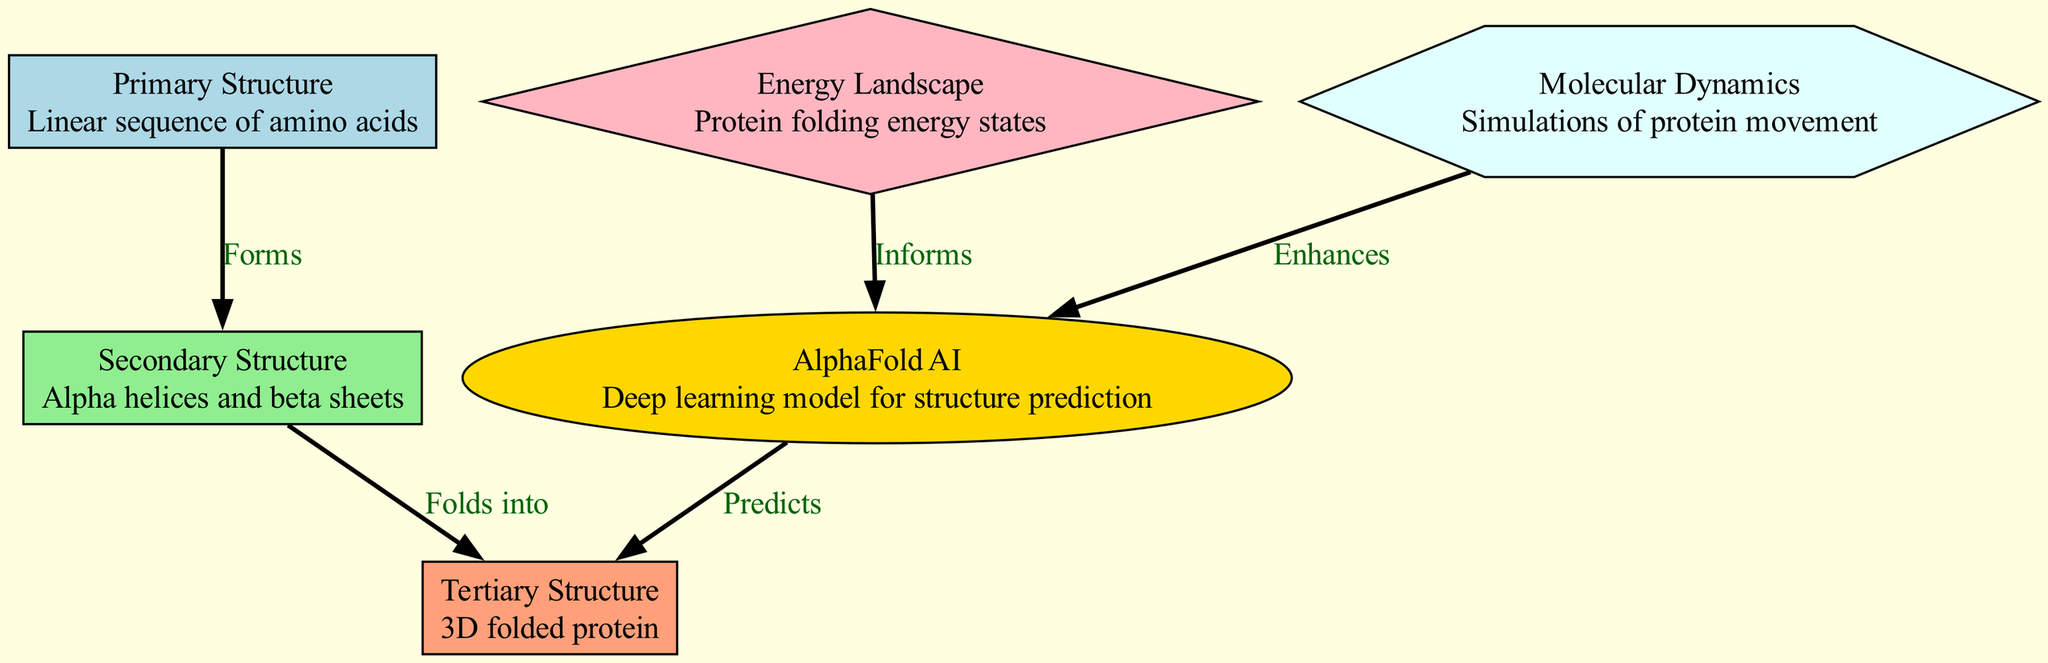What is the first step in protein folding? The diagram indicates that the primary structure, which is the linear sequence of amino acids, is the starting point of the protein folding process. This is the first node in the diagram.
Answer: Primary Structure How many distinct structures are outlined in the diagram? The diagram displays three distinct structures: primary, secondary, and tertiary. Each structure is represented as a node in the diagram, summing to a total of three.
Answer: 3 What type of AI model is used for predicting protein structures? According to the diagram, AlphaFold AI is identified as the deep learning model employed for predicting the 3D structures of proteins.
Answer: AlphaFold AI What does the secondary structure fold into? The diagram clearly shows that the secondary structure, which comprises alpha helices and beta sheets, folds into the tertiary structure. This relationship is indicated by an edge connecting the two nodes.
Answer: Tertiary Structure How does molecular dynamics contribute to AI predictions? The diagram states that molecular dynamics enhances the predictions made by AlphaFold AI. This indicates a supportive role in improving the accuracy or reliability of the predictions.
Answer: Enhances What informs the AlphaFold AI model? The diagram highlights that AlphaFold AI is informed by the energy landscape, which encompasses the energy states involved in protein folding. This connection is clearly depicted through a directed edge in the visualization.
Answer: Energy Landscape In terms of the energy landscape, what does it represent in the context of protein folding? The energy landscape represents the various energy states associated with the protein folding process. Each state suggests how proteins can adopt different conformations based on their energy levels during folding.
Answer: Protein folding energy states What two structures are directly connected by a 'Folds into' relationship? The diagram shows that the secondary structure directly folds into the tertiary structure, depicting a clear 'Folds into' relationship between these two types of protein structures.
Answer: Tertiary Structure How does AlphaFold AI utilize data from the energy landscape? The diagram indicates that AlphaFold AI is informed by the energy landscape, thus suggesting that it leverages this data to enhance its structure prediction capabilities.
Answer: Informs 